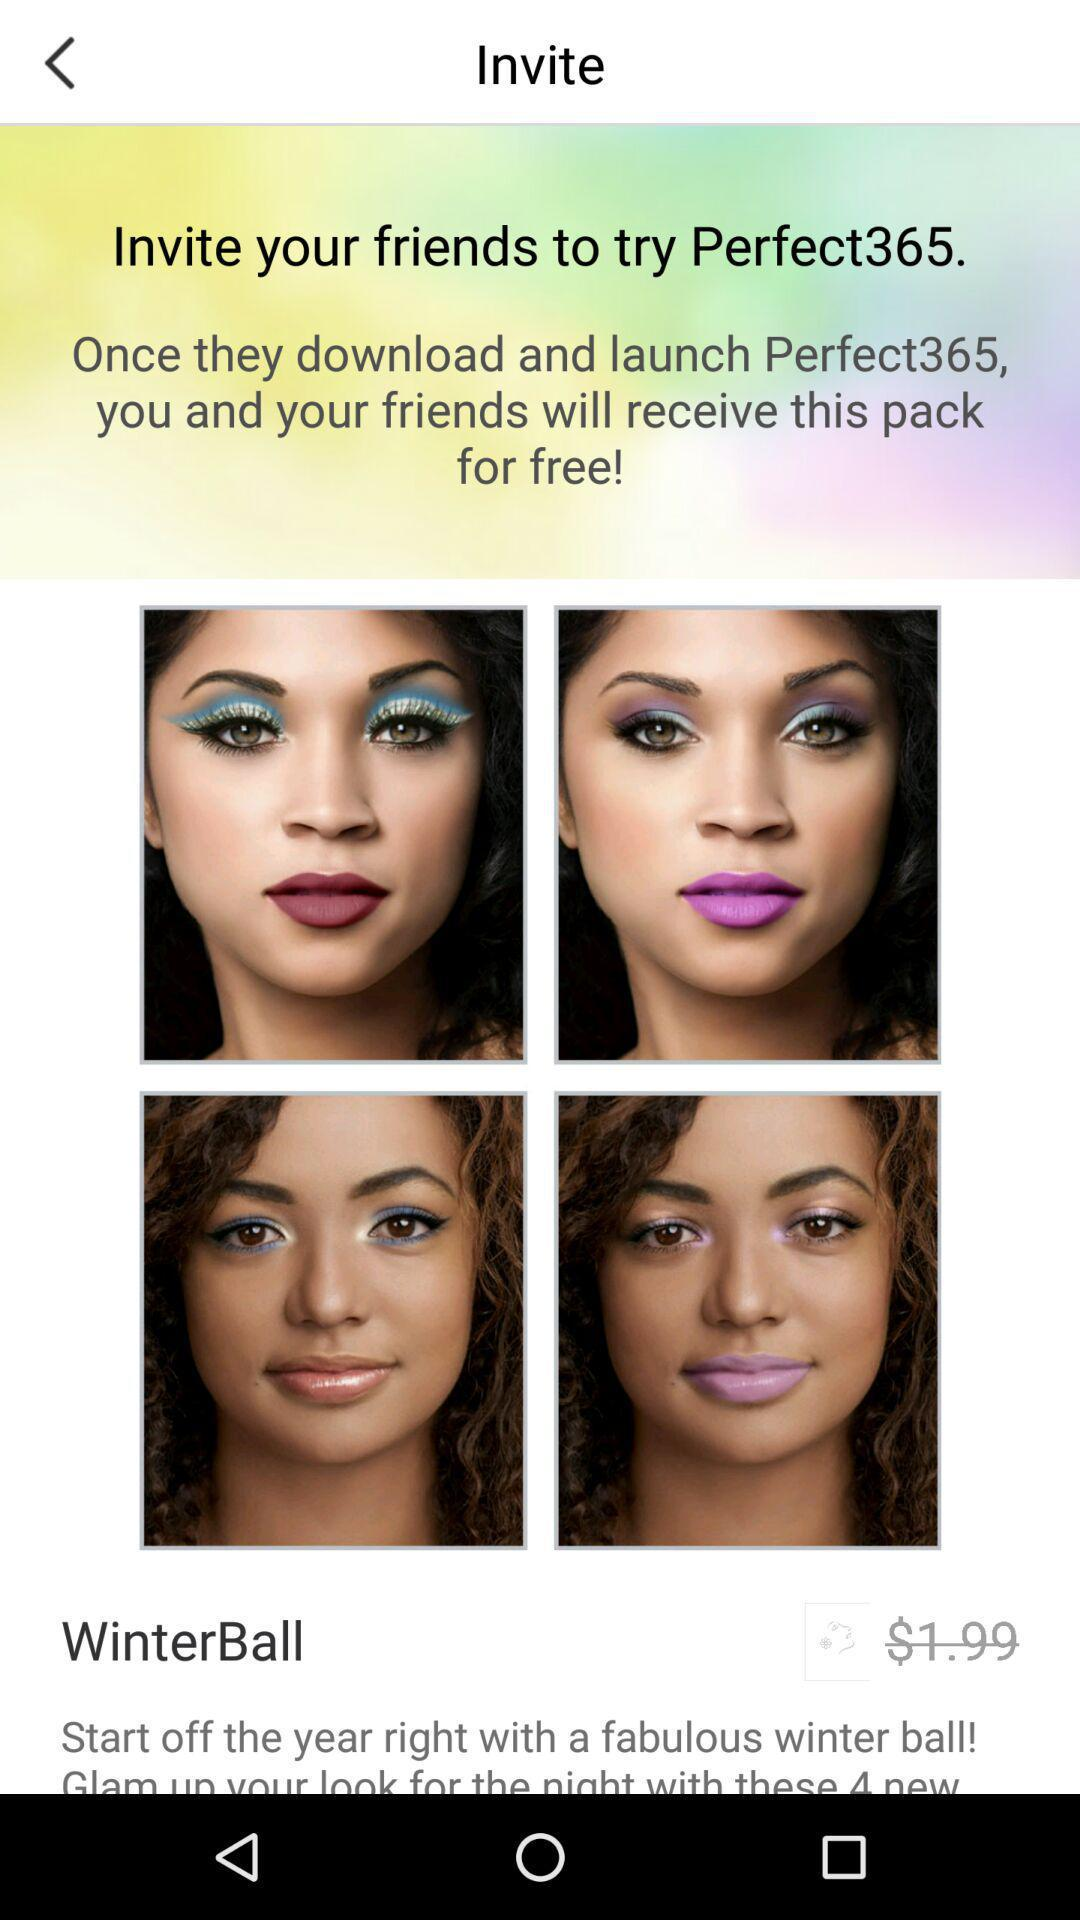How much will this pack cost me and my friends? You and your friends will receive this pack for free. 